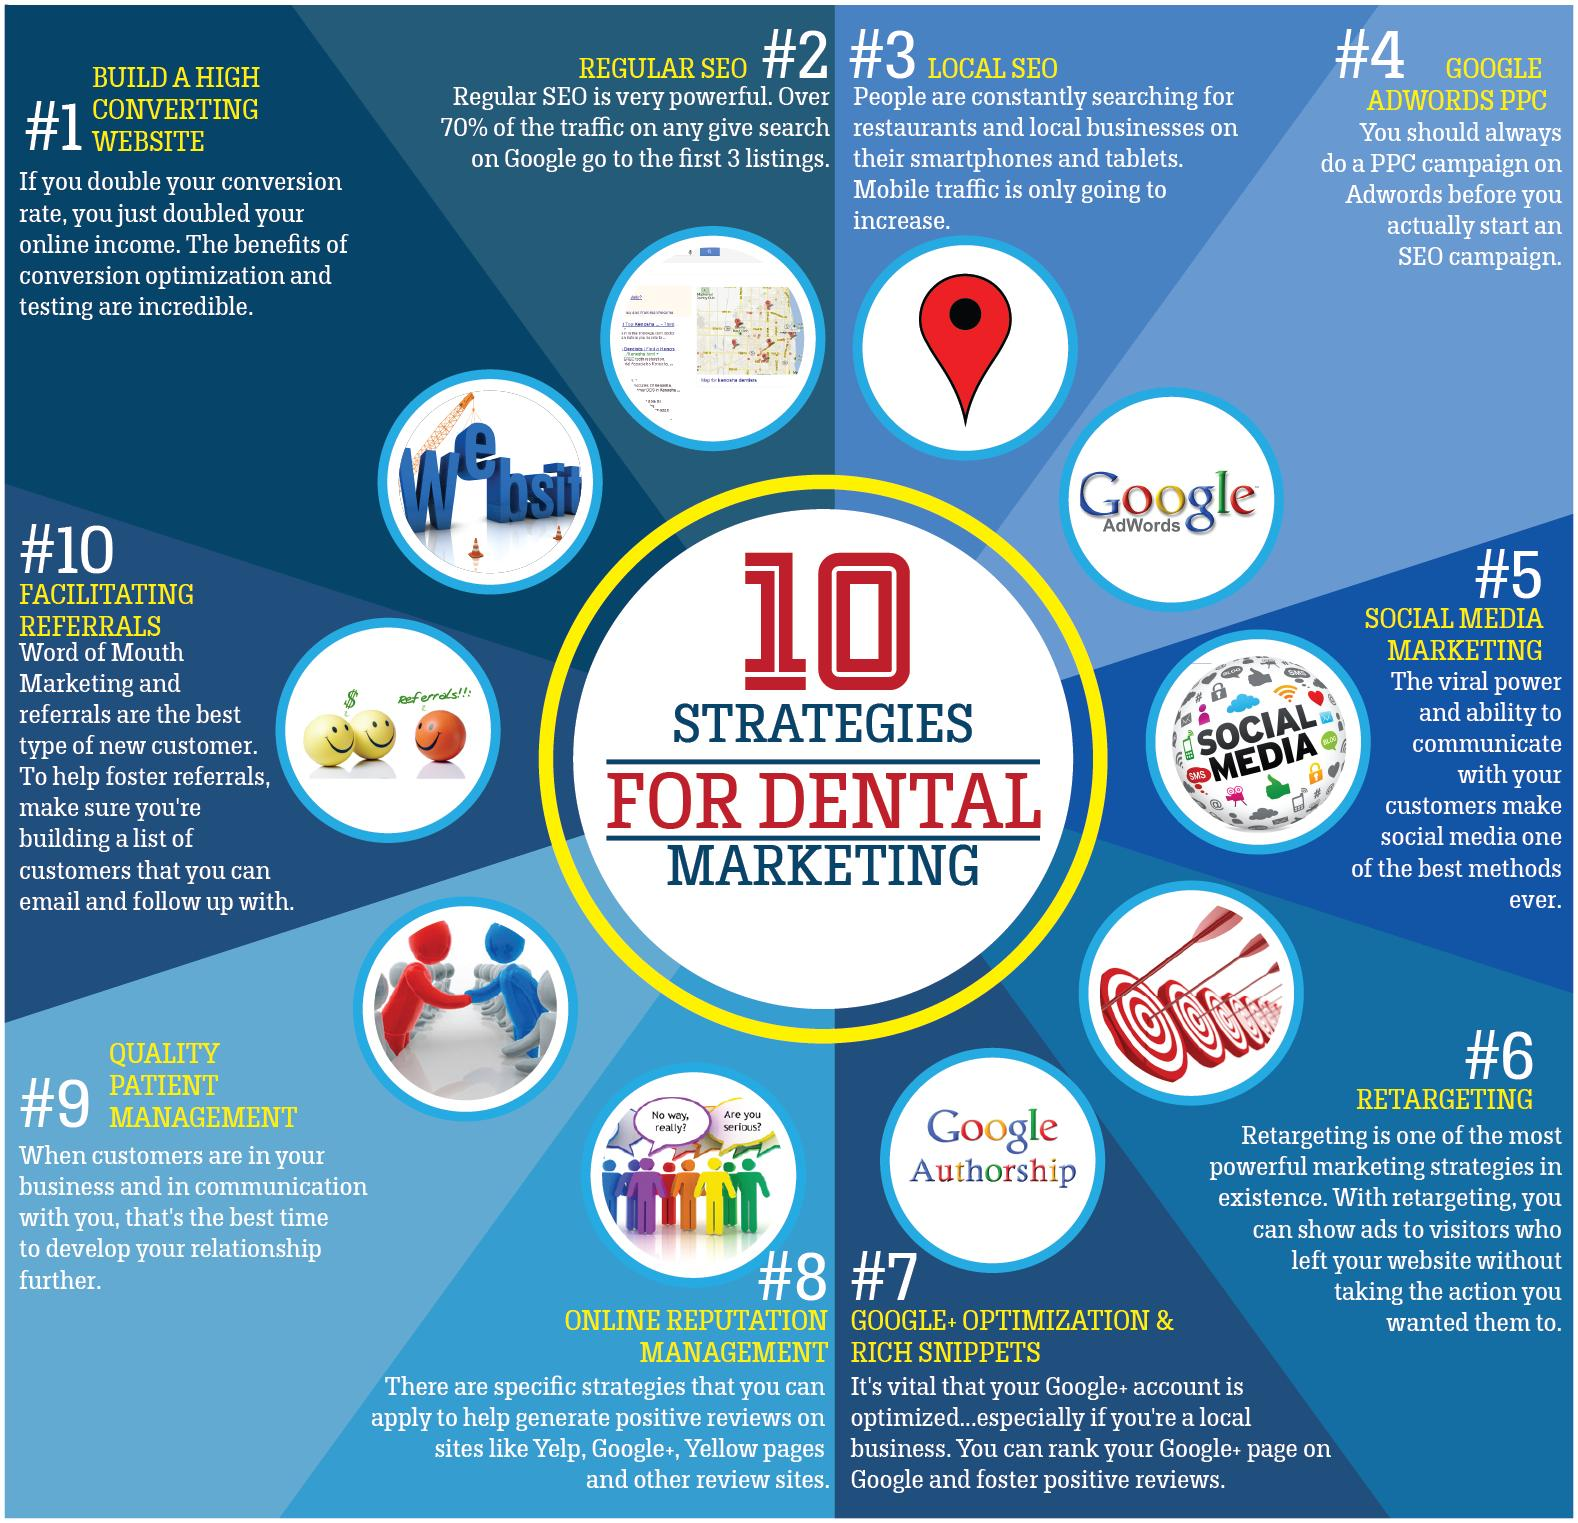Identify some key points in this picture. It is necessary to complete a Pay-Per-Click (PPC) campaign on AdWords prior to initiating an SEO campaign. Facilitating referrals is the 10th point in the list of ways to increase business and revenue. The two questions written in the image representing point 8 are 'No way, really?' and 'Are you serious?' It is written above the orange smiley that referrals are present:... The eighth point is online reputation management. 